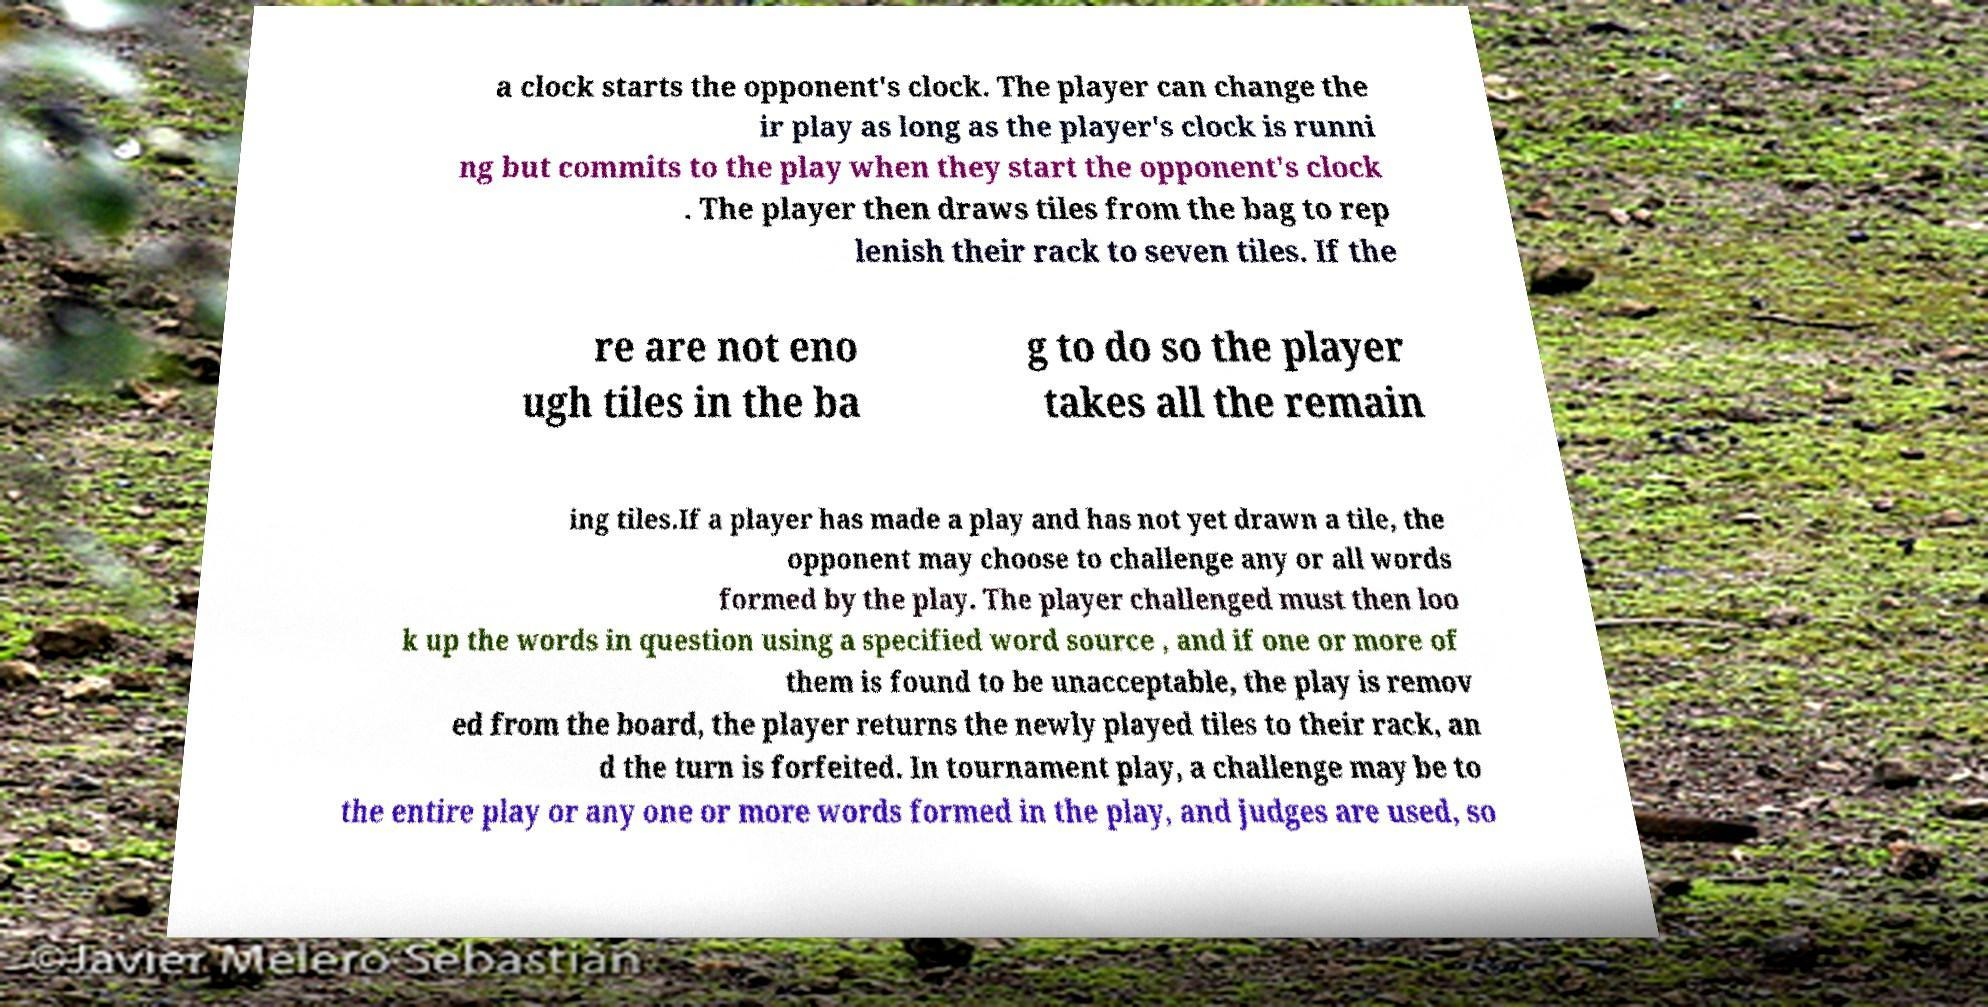Could you assist in decoding the text presented in this image and type it out clearly? a clock starts the opponent's clock. The player can change the ir play as long as the player's clock is runni ng but commits to the play when they start the opponent's clock . The player then draws tiles from the bag to rep lenish their rack to seven tiles. If the re are not eno ugh tiles in the ba g to do so the player takes all the remain ing tiles.If a player has made a play and has not yet drawn a tile, the opponent may choose to challenge any or all words formed by the play. The player challenged must then loo k up the words in question using a specified word source , and if one or more of them is found to be unacceptable, the play is remov ed from the board, the player returns the newly played tiles to their rack, an d the turn is forfeited. In tournament play, a challenge may be to the entire play or any one or more words formed in the play, and judges are used, so 